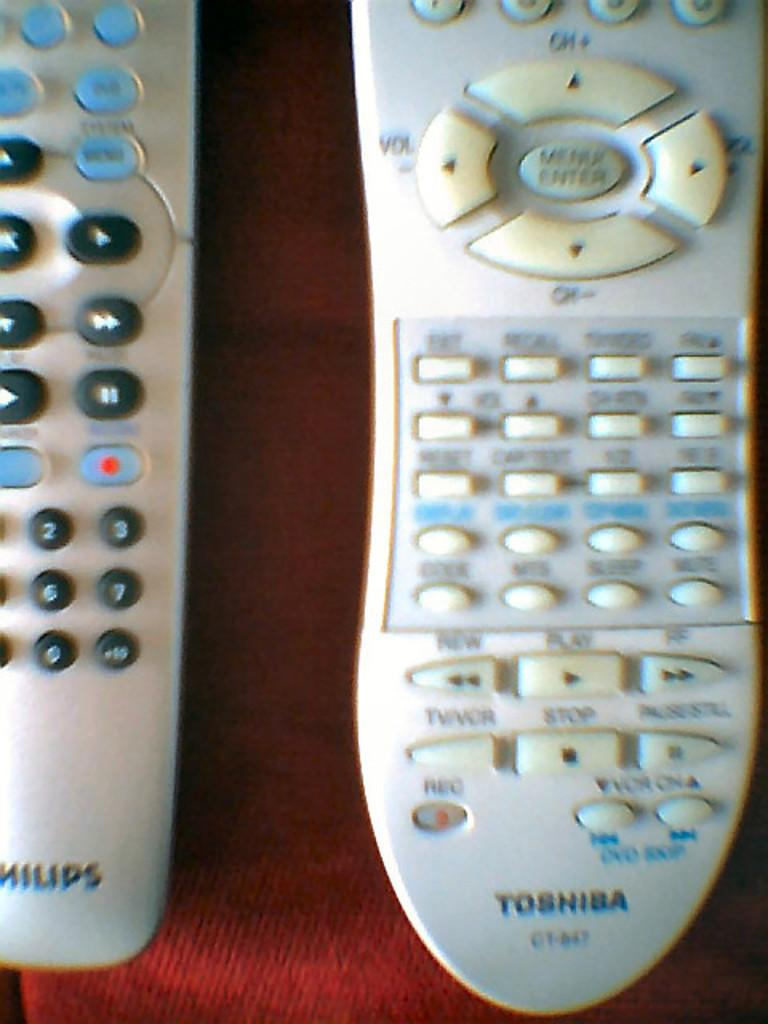What objects are on the table in the image? There are two remotes on the table. What features do the remotes have? The remotes have buttons and text. What type of machine is visible in the image? There is no machine present in the image. Can you describe the face of the person holding the remotes? There is no person present in the image, so it is not possible to describe their face. 